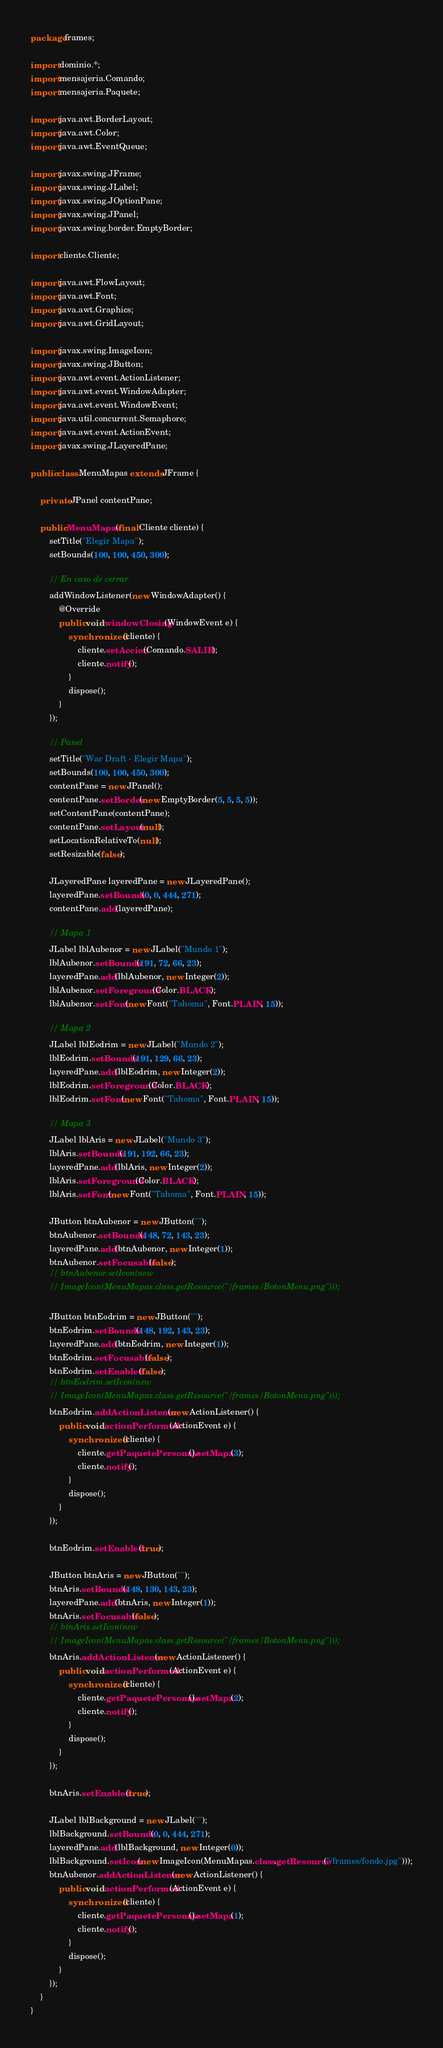Convert code to text. <code><loc_0><loc_0><loc_500><loc_500><_Java_>package frames;

import dominio.*;
import mensajeria.Comando;
import mensajeria.Paquete;

import java.awt.BorderLayout;
import java.awt.Color;
import java.awt.EventQueue;

import javax.swing.JFrame;
import javax.swing.JLabel;
import javax.swing.JOptionPane;
import javax.swing.JPanel;
import javax.swing.border.EmptyBorder;

import cliente.Cliente;

import java.awt.FlowLayout;
import java.awt.Font;
import java.awt.Graphics;
import java.awt.GridLayout;

import javax.swing.ImageIcon;
import javax.swing.JButton;
import java.awt.event.ActionListener;
import java.awt.event.WindowAdapter;
import java.awt.event.WindowEvent;
import java.util.concurrent.Semaphore;
import java.awt.event.ActionEvent;
import javax.swing.JLayeredPane;

public class MenuMapas extends JFrame {

	private JPanel contentPane;

	public MenuMapas(final Cliente cliente) {
		setTitle("Elegir Mapa");
		setBounds(100, 100, 450, 300);

		// En caso de cerrar
		addWindowListener(new WindowAdapter() {
			@Override
			public void windowClosing(WindowEvent e) {
				synchronized (cliente) {
					cliente.setAccion(Comando.SALIR);
					cliente.notify();
				}
				dispose();
			}
		});

		// Panel
		setTitle("War Draft - Elegir Mapa");
		setBounds(100, 100, 450, 300);
		contentPane = new JPanel();
		contentPane.setBorder(new EmptyBorder(5, 5, 5, 5));
		setContentPane(contentPane);
		contentPane.setLayout(null);
		setLocationRelativeTo(null);
		setResizable(false);

		JLayeredPane layeredPane = new JLayeredPane();
		layeredPane.setBounds(0, 0, 444, 271);
		contentPane.add(layeredPane);

		// Mapa 1
		JLabel lblAubenor = new JLabel("Mundo 1");
		lblAubenor.setBounds(191, 72, 66, 23);
		layeredPane.add(lblAubenor, new Integer(2));
		lblAubenor.setForeground(Color.BLACK);
		lblAubenor.setFont(new Font("Tahoma", Font.PLAIN, 15));

		// Mapa 2
		JLabel lblEodrim = new JLabel("Mundo 2");
		lblEodrim.setBounds(191, 129, 66, 23);
		layeredPane.add(lblEodrim, new Integer(2));
		lblEodrim.setForeground(Color.BLACK);
		lblEodrim.setFont(new Font("Tahoma", Font.PLAIN, 15));

		// Mapa 3
		JLabel lblAris = new JLabel("Mundo 3");
		lblAris.setBounds(191, 192, 66, 23);
		layeredPane.add(lblAris, new Integer(2));
		lblAris.setForeground(Color.BLACK);
		lblAris.setFont(new Font("Tahoma", Font.PLAIN, 15));

		JButton btnAubenor = new JButton("");
		btnAubenor.setBounds(148, 72, 143, 23);
		layeredPane.add(btnAubenor, new Integer(1));
		btnAubenor.setFocusable(false);
		// btnAubenor.setIcon(new
		// ImageIcon(MenuMapas.class.getResource("/frames/BotonMenu.png")));

		JButton btnEodrim = new JButton("");
		btnEodrim.setBounds(148, 192, 143, 23);
		layeredPane.add(btnEodrim, new Integer(1));
		btnEodrim.setFocusable(false);
		btnEodrim.setEnabled(false);
		// btnEodrim.setIcon(new
		// ImageIcon(MenuMapas.class.getResource("/frames/BotonMenu.png")));
		btnEodrim.addActionListener(new ActionListener() {
			public void actionPerformed(ActionEvent e) {
				synchronized (cliente) {
					cliente.getPaquetePersonaje().setMapa(3);
					cliente.notify();
				}
				dispose();
			}
		});

		btnEodrim.setEnabled(true);

		JButton btnAris = new JButton("");
		btnAris.setBounds(148, 130, 143, 23);
		layeredPane.add(btnAris, new Integer(1));
		btnAris.setFocusable(false);
		// btnAris.setIcon(new
		// ImageIcon(MenuMapas.class.getResource("/frames/BotonMenu.png")));
		btnAris.addActionListener(new ActionListener() {
			public void actionPerformed(ActionEvent e) {
				synchronized (cliente) {
					cliente.getPaquetePersonaje().setMapa(2);
					cliente.notify();
				}
				dispose();
			}
		});

		btnAris.setEnabled(true);

		JLabel lblBackground = new JLabel("");
		lblBackground.setBounds(0, 0, 444, 271);
		layeredPane.add(lblBackground, new Integer(0));
		lblBackground.setIcon(new ImageIcon(MenuMapas.class.getResource("/frames/fondo.jpg")));
		btnAubenor.addActionListener(new ActionListener() {
			public void actionPerformed(ActionEvent e) {
				synchronized (cliente) {
					cliente.getPaquetePersonaje().setMapa(1);
					cliente.notify();
				}
				dispose();
			}
		});
	}
}
</code> 